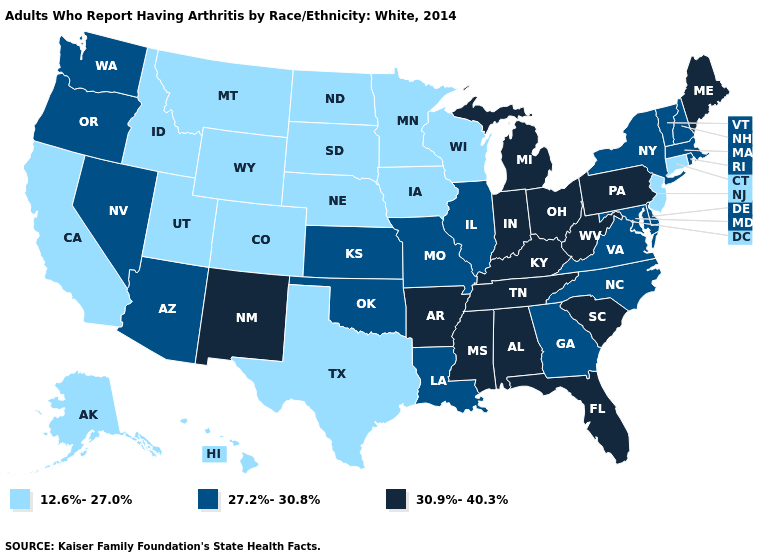Which states have the highest value in the USA?
Answer briefly. Alabama, Arkansas, Florida, Indiana, Kentucky, Maine, Michigan, Mississippi, New Mexico, Ohio, Pennsylvania, South Carolina, Tennessee, West Virginia. Which states have the lowest value in the USA?
Short answer required. Alaska, California, Colorado, Connecticut, Hawaii, Idaho, Iowa, Minnesota, Montana, Nebraska, New Jersey, North Dakota, South Dakota, Texas, Utah, Wisconsin, Wyoming. What is the value of Massachusetts?
Quick response, please. 27.2%-30.8%. Which states have the highest value in the USA?
Write a very short answer. Alabama, Arkansas, Florida, Indiana, Kentucky, Maine, Michigan, Mississippi, New Mexico, Ohio, Pennsylvania, South Carolina, Tennessee, West Virginia. Name the states that have a value in the range 12.6%-27.0%?
Concise answer only. Alaska, California, Colorado, Connecticut, Hawaii, Idaho, Iowa, Minnesota, Montana, Nebraska, New Jersey, North Dakota, South Dakota, Texas, Utah, Wisconsin, Wyoming. Does Illinois have the lowest value in the MidWest?
Be succinct. No. Among the states that border Nevada , which have the highest value?
Answer briefly. Arizona, Oregon. Does Georgia have the lowest value in the USA?
Give a very brief answer. No. Does the map have missing data?
Quick response, please. No. Among the states that border Indiana , does Illinois have the lowest value?
Be succinct. Yes. Name the states that have a value in the range 27.2%-30.8%?
Give a very brief answer. Arizona, Delaware, Georgia, Illinois, Kansas, Louisiana, Maryland, Massachusetts, Missouri, Nevada, New Hampshire, New York, North Carolina, Oklahoma, Oregon, Rhode Island, Vermont, Virginia, Washington. Does the first symbol in the legend represent the smallest category?
Short answer required. Yes. Which states have the lowest value in the USA?
Concise answer only. Alaska, California, Colorado, Connecticut, Hawaii, Idaho, Iowa, Minnesota, Montana, Nebraska, New Jersey, North Dakota, South Dakota, Texas, Utah, Wisconsin, Wyoming. Is the legend a continuous bar?
Concise answer only. No. 